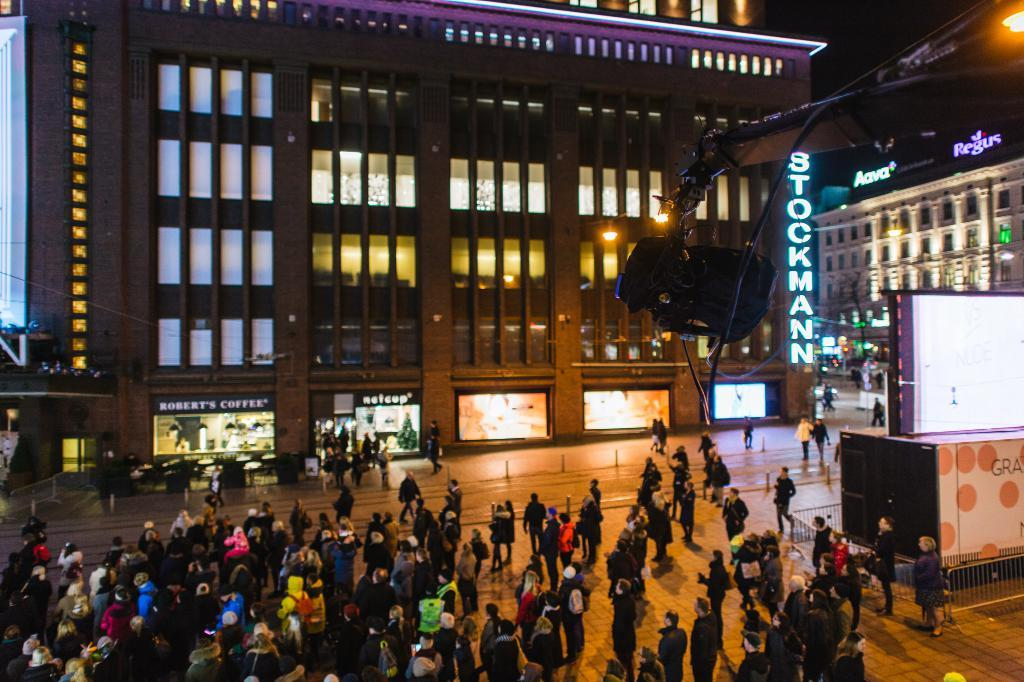<image>
Summarize the visual content of the image. the word Stockman is on a sign next to a building 